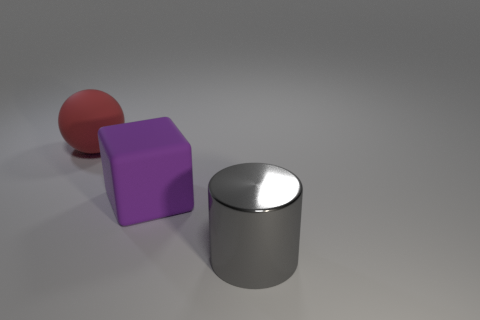Can you guess the size of these objects relative to each other? Relative to each other, the ball appears to be the smallest object, the purple block seems to be slightly larger, and the cylindrical object comes across as the largest both in height and volume. Without additional context or objects for scale, exact size estimations are challenging. 